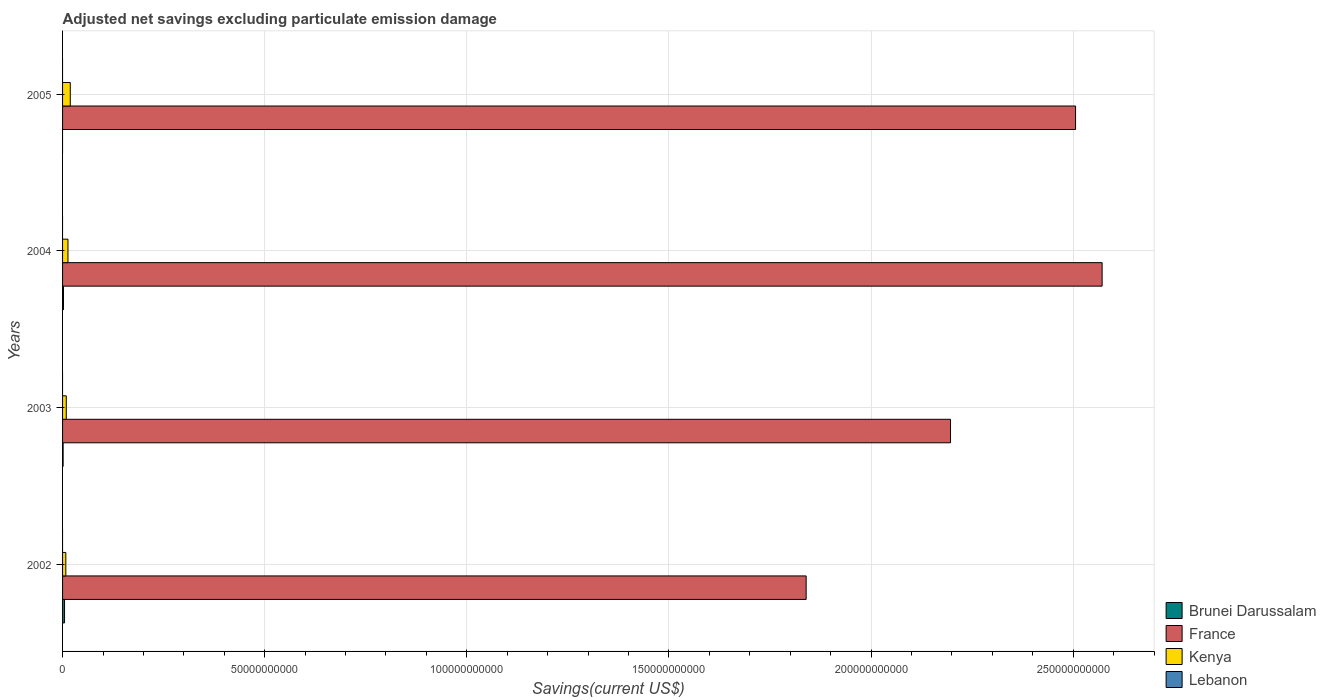How many different coloured bars are there?
Provide a short and direct response. 3. Are the number of bars on each tick of the Y-axis equal?
Your answer should be very brief. No. Across all years, what is the maximum adjusted net savings in Kenya?
Provide a succinct answer. 1.91e+09. In which year was the adjusted net savings in Kenya maximum?
Provide a short and direct response. 2005. What is the total adjusted net savings in Kenya in the graph?
Your response must be concise. 4.97e+09. What is the difference between the adjusted net savings in Kenya in 2003 and that in 2005?
Provide a short and direct response. -9.89e+08. What is the difference between the adjusted net savings in France in 2005 and the adjusted net savings in Kenya in 2003?
Offer a very short reply. 2.50e+11. What is the average adjusted net savings in France per year?
Offer a very short reply. 2.28e+11. In the year 2004, what is the difference between the adjusted net savings in France and adjusted net savings in Brunei Darussalam?
Ensure brevity in your answer.  2.57e+11. What is the ratio of the adjusted net savings in France in 2002 to that in 2005?
Your answer should be compact. 0.73. What is the difference between the highest and the second highest adjusted net savings in Kenya?
Your response must be concise. 5.69e+08. What is the difference between the highest and the lowest adjusted net savings in France?
Keep it short and to the point. 7.32e+1. Is the sum of the adjusted net savings in Kenya in 2002 and 2003 greater than the maximum adjusted net savings in Lebanon across all years?
Offer a very short reply. Yes. Is it the case that in every year, the sum of the adjusted net savings in France and adjusted net savings in Lebanon is greater than the adjusted net savings in Kenya?
Provide a short and direct response. Yes. How many years are there in the graph?
Provide a short and direct response. 4. What is the difference between two consecutive major ticks on the X-axis?
Keep it short and to the point. 5.00e+1. Does the graph contain any zero values?
Your answer should be compact. Yes. Where does the legend appear in the graph?
Provide a short and direct response. Bottom right. How are the legend labels stacked?
Your response must be concise. Vertical. What is the title of the graph?
Offer a very short reply. Adjusted net savings excluding particulate emission damage. Does "North America" appear as one of the legend labels in the graph?
Offer a very short reply. No. What is the label or title of the X-axis?
Give a very brief answer. Savings(current US$). What is the label or title of the Y-axis?
Make the answer very short. Years. What is the Savings(current US$) in Brunei Darussalam in 2002?
Your response must be concise. 4.88e+08. What is the Savings(current US$) of France in 2002?
Offer a very short reply. 1.84e+11. What is the Savings(current US$) of Kenya in 2002?
Keep it short and to the point. 8.08e+08. What is the Savings(current US$) in Lebanon in 2002?
Make the answer very short. 0. What is the Savings(current US$) of Brunei Darussalam in 2003?
Give a very brief answer. 1.37e+08. What is the Savings(current US$) in France in 2003?
Provide a short and direct response. 2.20e+11. What is the Savings(current US$) of Kenya in 2003?
Give a very brief answer. 9.18e+08. What is the Savings(current US$) in Lebanon in 2003?
Ensure brevity in your answer.  0. What is the Savings(current US$) in Brunei Darussalam in 2004?
Ensure brevity in your answer.  2.27e+08. What is the Savings(current US$) of France in 2004?
Your response must be concise. 2.57e+11. What is the Savings(current US$) of Kenya in 2004?
Give a very brief answer. 1.34e+09. What is the Savings(current US$) in Lebanon in 2004?
Offer a very short reply. 0. What is the Savings(current US$) of Brunei Darussalam in 2005?
Offer a terse response. 0. What is the Savings(current US$) of France in 2005?
Offer a very short reply. 2.51e+11. What is the Savings(current US$) of Kenya in 2005?
Give a very brief answer. 1.91e+09. Across all years, what is the maximum Savings(current US$) of Brunei Darussalam?
Provide a succinct answer. 4.88e+08. Across all years, what is the maximum Savings(current US$) of France?
Provide a short and direct response. 2.57e+11. Across all years, what is the maximum Savings(current US$) in Kenya?
Keep it short and to the point. 1.91e+09. Across all years, what is the minimum Savings(current US$) of France?
Keep it short and to the point. 1.84e+11. Across all years, what is the minimum Savings(current US$) in Kenya?
Provide a short and direct response. 8.08e+08. What is the total Savings(current US$) in Brunei Darussalam in the graph?
Provide a succinct answer. 8.52e+08. What is the total Savings(current US$) in France in the graph?
Provide a short and direct response. 9.11e+11. What is the total Savings(current US$) of Kenya in the graph?
Offer a terse response. 4.97e+09. What is the total Savings(current US$) in Lebanon in the graph?
Your response must be concise. 0. What is the difference between the Savings(current US$) in Brunei Darussalam in 2002 and that in 2003?
Provide a short and direct response. 3.51e+08. What is the difference between the Savings(current US$) of France in 2002 and that in 2003?
Your answer should be very brief. -3.57e+1. What is the difference between the Savings(current US$) of Kenya in 2002 and that in 2003?
Keep it short and to the point. -1.10e+08. What is the difference between the Savings(current US$) of Brunei Darussalam in 2002 and that in 2004?
Your answer should be compact. 2.62e+08. What is the difference between the Savings(current US$) of France in 2002 and that in 2004?
Your response must be concise. -7.32e+1. What is the difference between the Savings(current US$) of Kenya in 2002 and that in 2004?
Provide a short and direct response. -5.30e+08. What is the difference between the Savings(current US$) in France in 2002 and that in 2005?
Make the answer very short. -6.66e+1. What is the difference between the Savings(current US$) in Kenya in 2002 and that in 2005?
Give a very brief answer. -1.10e+09. What is the difference between the Savings(current US$) in Brunei Darussalam in 2003 and that in 2004?
Your response must be concise. -8.97e+07. What is the difference between the Savings(current US$) in France in 2003 and that in 2004?
Provide a short and direct response. -3.75e+1. What is the difference between the Savings(current US$) of Kenya in 2003 and that in 2004?
Provide a succinct answer. -4.20e+08. What is the difference between the Savings(current US$) in France in 2003 and that in 2005?
Offer a very short reply. -3.09e+1. What is the difference between the Savings(current US$) of Kenya in 2003 and that in 2005?
Keep it short and to the point. -9.89e+08. What is the difference between the Savings(current US$) in France in 2004 and that in 2005?
Your response must be concise. 6.57e+09. What is the difference between the Savings(current US$) in Kenya in 2004 and that in 2005?
Offer a very short reply. -5.69e+08. What is the difference between the Savings(current US$) in Brunei Darussalam in 2002 and the Savings(current US$) in France in 2003?
Your response must be concise. -2.19e+11. What is the difference between the Savings(current US$) in Brunei Darussalam in 2002 and the Savings(current US$) in Kenya in 2003?
Offer a very short reply. -4.30e+08. What is the difference between the Savings(current US$) in France in 2002 and the Savings(current US$) in Kenya in 2003?
Provide a succinct answer. 1.83e+11. What is the difference between the Savings(current US$) in Brunei Darussalam in 2002 and the Savings(current US$) in France in 2004?
Your answer should be compact. -2.57e+11. What is the difference between the Savings(current US$) of Brunei Darussalam in 2002 and the Savings(current US$) of Kenya in 2004?
Give a very brief answer. -8.50e+08. What is the difference between the Savings(current US$) in France in 2002 and the Savings(current US$) in Kenya in 2004?
Offer a terse response. 1.83e+11. What is the difference between the Savings(current US$) in Brunei Darussalam in 2002 and the Savings(current US$) in France in 2005?
Your answer should be very brief. -2.50e+11. What is the difference between the Savings(current US$) of Brunei Darussalam in 2002 and the Savings(current US$) of Kenya in 2005?
Offer a very short reply. -1.42e+09. What is the difference between the Savings(current US$) of France in 2002 and the Savings(current US$) of Kenya in 2005?
Keep it short and to the point. 1.82e+11. What is the difference between the Savings(current US$) in Brunei Darussalam in 2003 and the Savings(current US$) in France in 2004?
Your answer should be compact. -2.57e+11. What is the difference between the Savings(current US$) in Brunei Darussalam in 2003 and the Savings(current US$) in Kenya in 2004?
Offer a terse response. -1.20e+09. What is the difference between the Savings(current US$) in France in 2003 and the Savings(current US$) in Kenya in 2004?
Ensure brevity in your answer.  2.18e+11. What is the difference between the Savings(current US$) in Brunei Darussalam in 2003 and the Savings(current US$) in France in 2005?
Your answer should be compact. -2.50e+11. What is the difference between the Savings(current US$) in Brunei Darussalam in 2003 and the Savings(current US$) in Kenya in 2005?
Give a very brief answer. -1.77e+09. What is the difference between the Savings(current US$) in France in 2003 and the Savings(current US$) in Kenya in 2005?
Ensure brevity in your answer.  2.18e+11. What is the difference between the Savings(current US$) of Brunei Darussalam in 2004 and the Savings(current US$) of France in 2005?
Offer a very short reply. -2.50e+11. What is the difference between the Savings(current US$) in Brunei Darussalam in 2004 and the Savings(current US$) in Kenya in 2005?
Make the answer very short. -1.68e+09. What is the difference between the Savings(current US$) of France in 2004 and the Savings(current US$) of Kenya in 2005?
Make the answer very short. 2.55e+11. What is the average Savings(current US$) in Brunei Darussalam per year?
Make the answer very short. 2.13e+08. What is the average Savings(current US$) of France per year?
Offer a very short reply. 2.28e+11. What is the average Savings(current US$) in Kenya per year?
Ensure brevity in your answer.  1.24e+09. In the year 2002, what is the difference between the Savings(current US$) of Brunei Darussalam and Savings(current US$) of France?
Provide a succinct answer. -1.83e+11. In the year 2002, what is the difference between the Savings(current US$) of Brunei Darussalam and Savings(current US$) of Kenya?
Provide a succinct answer. -3.20e+08. In the year 2002, what is the difference between the Savings(current US$) of France and Savings(current US$) of Kenya?
Offer a very short reply. 1.83e+11. In the year 2003, what is the difference between the Savings(current US$) of Brunei Darussalam and Savings(current US$) of France?
Keep it short and to the point. -2.20e+11. In the year 2003, what is the difference between the Savings(current US$) in Brunei Darussalam and Savings(current US$) in Kenya?
Provide a succinct answer. -7.81e+08. In the year 2003, what is the difference between the Savings(current US$) of France and Savings(current US$) of Kenya?
Keep it short and to the point. 2.19e+11. In the year 2004, what is the difference between the Savings(current US$) in Brunei Darussalam and Savings(current US$) in France?
Your answer should be compact. -2.57e+11. In the year 2004, what is the difference between the Savings(current US$) in Brunei Darussalam and Savings(current US$) in Kenya?
Ensure brevity in your answer.  -1.11e+09. In the year 2004, what is the difference between the Savings(current US$) in France and Savings(current US$) in Kenya?
Offer a very short reply. 2.56e+11. In the year 2005, what is the difference between the Savings(current US$) of France and Savings(current US$) of Kenya?
Ensure brevity in your answer.  2.49e+11. What is the ratio of the Savings(current US$) in Brunei Darussalam in 2002 to that in 2003?
Your answer should be very brief. 3.57. What is the ratio of the Savings(current US$) in France in 2002 to that in 2003?
Your answer should be very brief. 0.84. What is the ratio of the Savings(current US$) in Kenya in 2002 to that in 2003?
Provide a short and direct response. 0.88. What is the ratio of the Savings(current US$) of Brunei Darussalam in 2002 to that in 2004?
Your answer should be very brief. 2.15. What is the ratio of the Savings(current US$) in France in 2002 to that in 2004?
Your response must be concise. 0.72. What is the ratio of the Savings(current US$) in Kenya in 2002 to that in 2004?
Ensure brevity in your answer.  0.6. What is the ratio of the Savings(current US$) in France in 2002 to that in 2005?
Your answer should be compact. 0.73. What is the ratio of the Savings(current US$) of Kenya in 2002 to that in 2005?
Your response must be concise. 0.42. What is the ratio of the Savings(current US$) of Brunei Darussalam in 2003 to that in 2004?
Ensure brevity in your answer.  0.6. What is the ratio of the Savings(current US$) of France in 2003 to that in 2004?
Keep it short and to the point. 0.85. What is the ratio of the Savings(current US$) in Kenya in 2003 to that in 2004?
Keep it short and to the point. 0.69. What is the ratio of the Savings(current US$) of France in 2003 to that in 2005?
Provide a short and direct response. 0.88. What is the ratio of the Savings(current US$) of Kenya in 2003 to that in 2005?
Give a very brief answer. 0.48. What is the ratio of the Savings(current US$) in France in 2004 to that in 2005?
Give a very brief answer. 1.03. What is the ratio of the Savings(current US$) in Kenya in 2004 to that in 2005?
Keep it short and to the point. 0.7. What is the difference between the highest and the second highest Savings(current US$) in Brunei Darussalam?
Your answer should be very brief. 2.62e+08. What is the difference between the highest and the second highest Savings(current US$) in France?
Give a very brief answer. 6.57e+09. What is the difference between the highest and the second highest Savings(current US$) of Kenya?
Your answer should be very brief. 5.69e+08. What is the difference between the highest and the lowest Savings(current US$) of Brunei Darussalam?
Your answer should be compact. 4.88e+08. What is the difference between the highest and the lowest Savings(current US$) in France?
Give a very brief answer. 7.32e+1. What is the difference between the highest and the lowest Savings(current US$) of Kenya?
Ensure brevity in your answer.  1.10e+09. 